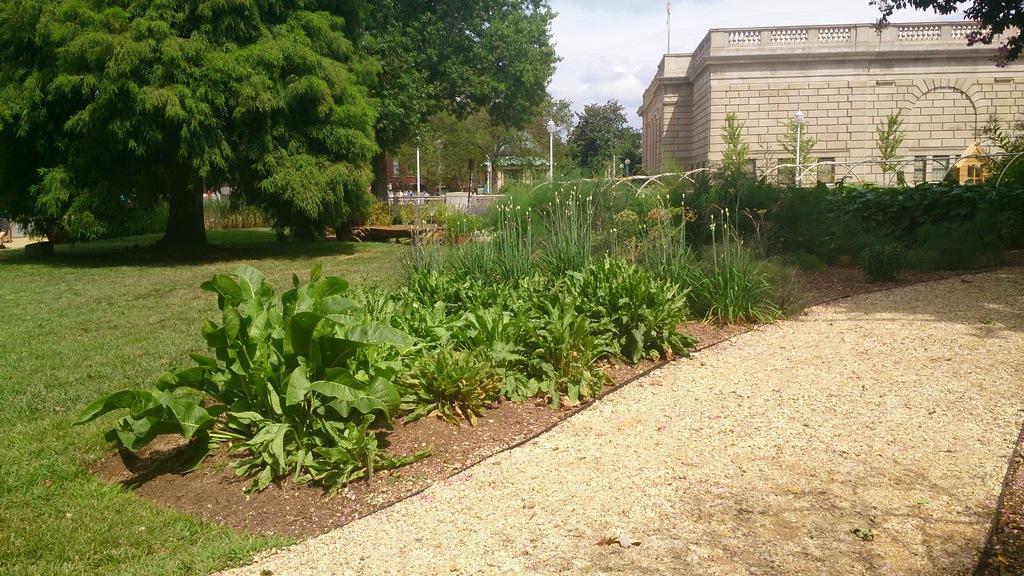Can you describe this image briefly? In the picture I can see the walkway on the right side. There are plants on the side of the walkway. There is a building on the right side. I can see the decorative lamp poles in front of the building. I can see the trees and green grass on the left side. There are clouds in the sky. 